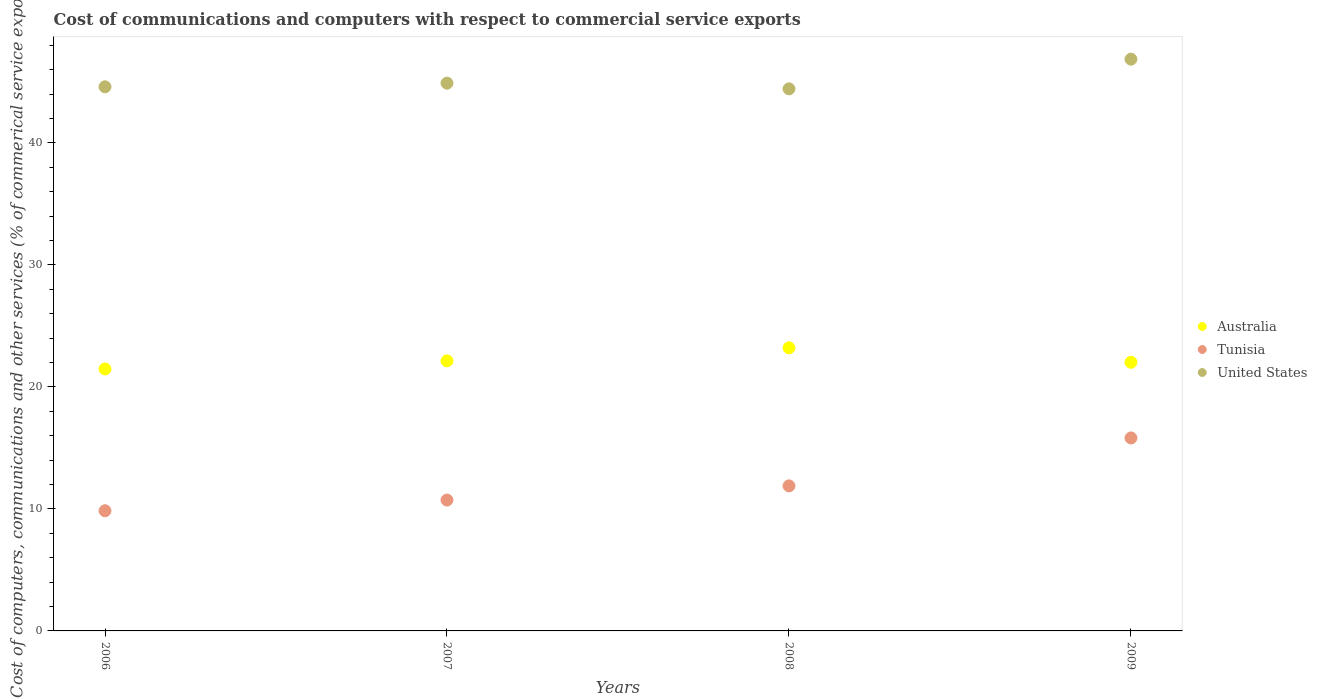How many different coloured dotlines are there?
Offer a terse response. 3. Is the number of dotlines equal to the number of legend labels?
Provide a succinct answer. Yes. What is the cost of communications and computers in United States in 2009?
Provide a short and direct response. 46.86. Across all years, what is the maximum cost of communications and computers in Australia?
Offer a terse response. 23.2. Across all years, what is the minimum cost of communications and computers in United States?
Provide a short and direct response. 44.43. In which year was the cost of communications and computers in Tunisia minimum?
Offer a very short reply. 2006. What is the total cost of communications and computers in Australia in the graph?
Offer a very short reply. 88.83. What is the difference between the cost of communications and computers in Tunisia in 2007 and that in 2009?
Provide a short and direct response. -5.09. What is the difference between the cost of communications and computers in United States in 2006 and the cost of communications and computers in Australia in 2007?
Provide a short and direct response. 22.46. What is the average cost of communications and computers in United States per year?
Provide a short and direct response. 45.2. In the year 2009, what is the difference between the cost of communications and computers in Tunisia and cost of communications and computers in Australia?
Provide a succinct answer. -6.2. In how many years, is the cost of communications and computers in Australia greater than 6 %?
Ensure brevity in your answer.  4. What is the ratio of the cost of communications and computers in Tunisia in 2008 to that in 2009?
Offer a very short reply. 0.75. Is the cost of communications and computers in United States in 2007 less than that in 2008?
Your answer should be compact. No. What is the difference between the highest and the second highest cost of communications and computers in Australia?
Offer a very short reply. 1.07. What is the difference between the highest and the lowest cost of communications and computers in Australia?
Your answer should be very brief. 1.73. In how many years, is the cost of communications and computers in Australia greater than the average cost of communications and computers in Australia taken over all years?
Offer a terse response. 1. Is the sum of the cost of communications and computers in Tunisia in 2006 and 2008 greater than the maximum cost of communications and computers in Australia across all years?
Your answer should be very brief. No. Is the cost of communications and computers in Australia strictly greater than the cost of communications and computers in United States over the years?
Ensure brevity in your answer.  No. How many dotlines are there?
Offer a terse response. 3. How many years are there in the graph?
Keep it short and to the point. 4. What is the difference between two consecutive major ticks on the Y-axis?
Your answer should be very brief. 10. Does the graph contain any zero values?
Your answer should be very brief. No. Where does the legend appear in the graph?
Offer a very short reply. Center right. How many legend labels are there?
Provide a short and direct response. 3. What is the title of the graph?
Your answer should be compact. Cost of communications and computers with respect to commercial service exports. Does "Uganda" appear as one of the legend labels in the graph?
Ensure brevity in your answer.  No. What is the label or title of the Y-axis?
Give a very brief answer. Cost of computers, communications and other services (% of commerical service exports). What is the Cost of computers, communications and other services (% of commerical service exports) of Australia in 2006?
Offer a terse response. 21.47. What is the Cost of computers, communications and other services (% of commerical service exports) of Tunisia in 2006?
Your answer should be compact. 9.85. What is the Cost of computers, communications and other services (% of commerical service exports) of United States in 2006?
Give a very brief answer. 44.6. What is the Cost of computers, communications and other services (% of commerical service exports) of Australia in 2007?
Keep it short and to the point. 22.14. What is the Cost of computers, communications and other services (% of commerical service exports) in Tunisia in 2007?
Offer a terse response. 10.73. What is the Cost of computers, communications and other services (% of commerical service exports) in United States in 2007?
Keep it short and to the point. 44.89. What is the Cost of computers, communications and other services (% of commerical service exports) in Australia in 2008?
Your response must be concise. 23.2. What is the Cost of computers, communications and other services (% of commerical service exports) of Tunisia in 2008?
Your answer should be compact. 11.89. What is the Cost of computers, communications and other services (% of commerical service exports) in United States in 2008?
Your answer should be very brief. 44.43. What is the Cost of computers, communications and other services (% of commerical service exports) in Australia in 2009?
Offer a very short reply. 22.02. What is the Cost of computers, communications and other services (% of commerical service exports) of Tunisia in 2009?
Ensure brevity in your answer.  15.82. What is the Cost of computers, communications and other services (% of commerical service exports) of United States in 2009?
Give a very brief answer. 46.86. Across all years, what is the maximum Cost of computers, communications and other services (% of commerical service exports) in Australia?
Offer a very short reply. 23.2. Across all years, what is the maximum Cost of computers, communications and other services (% of commerical service exports) in Tunisia?
Make the answer very short. 15.82. Across all years, what is the maximum Cost of computers, communications and other services (% of commerical service exports) of United States?
Provide a succinct answer. 46.86. Across all years, what is the minimum Cost of computers, communications and other services (% of commerical service exports) in Australia?
Your answer should be very brief. 21.47. Across all years, what is the minimum Cost of computers, communications and other services (% of commerical service exports) of Tunisia?
Provide a short and direct response. 9.85. Across all years, what is the minimum Cost of computers, communications and other services (% of commerical service exports) of United States?
Ensure brevity in your answer.  44.43. What is the total Cost of computers, communications and other services (% of commerical service exports) in Australia in the graph?
Offer a terse response. 88.83. What is the total Cost of computers, communications and other services (% of commerical service exports) of Tunisia in the graph?
Give a very brief answer. 48.28. What is the total Cost of computers, communications and other services (% of commerical service exports) of United States in the graph?
Keep it short and to the point. 180.78. What is the difference between the Cost of computers, communications and other services (% of commerical service exports) of Australia in 2006 and that in 2007?
Your answer should be very brief. -0.66. What is the difference between the Cost of computers, communications and other services (% of commerical service exports) of Tunisia in 2006 and that in 2007?
Give a very brief answer. -0.88. What is the difference between the Cost of computers, communications and other services (% of commerical service exports) in United States in 2006 and that in 2007?
Your response must be concise. -0.3. What is the difference between the Cost of computers, communications and other services (% of commerical service exports) in Australia in 2006 and that in 2008?
Ensure brevity in your answer.  -1.73. What is the difference between the Cost of computers, communications and other services (% of commerical service exports) of Tunisia in 2006 and that in 2008?
Provide a succinct answer. -2.04. What is the difference between the Cost of computers, communications and other services (% of commerical service exports) of United States in 2006 and that in 2008?
Offer a terse response. 0.17. What is the difference between the Cost of computers, communications and other services (% of commerical service exports) of Australia in 2006 and that in 2009?
Your answer should be very brief. -0.55. What is the difference between the Cost of computers, communications and other services (% of commerical service exports) of Tunisia in 2006 and that in 2009?
Your response must be concise. -5.97. What is the difference between the Cost of computers, communications and other services (% of commerical service exports) in United States in 2006 and that in 2009?
Ensure brevity in your answer.  -2.27. What is the difference between the Cost of computers, communications and other services (% of commerical service exports) in Australia in 2007 and that in 2008?
Offer a very short reply. -1.07. What is the difference between the Cost of computers, communications and other services (% of commerical service exports) of Tunisia in 2007 and that in 2008?
Make the answer very short. -1.16. What is the difference between the Cost of computers, communications and other services (% of commerical service exports) in United States in 2007 and that in 2008?
Provide a short and direct response. 0.46. What is the difference between the Cost of computers, communications and other services (% of commerical service exports) in Australia in 2007 and that in 2009?
Your answer should be compact. 0.12. What is the difference between the Cost of computers, communications and other services (% of commerical service exports) of Tunisia in 2007 and that in 2009?
Make the answer very short. -5.09. What is the difference between the Cost of computers, communications and other services (% of commerical service exports) in United States in 2007 and that in 2009?
Make the answer very short. -1.97. What is the difference between the Cost of computers, communications and other services (% of commerical service exports) of Australia in 2008 and that in 2009?
Offer a very short reply. 1.18. What is the difference between the Cost of computers, communications and other services (% of commerical service exports) in Tunisia in 2008 and that in 2009?
Ensure brevity in your answer.  -3.93. What is the difference between the Cost of computers, communications and other services (% of commerical service exports) in United States in 2008 and that in 2009?
Ensure brevity in your answer.  -2.43. What is the difference between the Cost of computers, communications and other services (% of commerical service exports) in Australia in 2006 and the Cost of computers, communications and other services (% of commerical service exports) in Tunisia in 2007?
Give a very brief answer. 10.75. What is the difference between the Cost of computers, communications and other services (% of commerical service exports) of Australia in 2006 and the Cost of computers, communications and other services (% of commerical service exports) of United States in 2007?
Your answer should be compact. -23.42. What is the difference between the Cost of computers, communications and other services (% of commerical service exports) of Tunisia in 2006 and the Cost of computers, communications and other services (% of commerical service exports) of United States in 2007?
Keep it short and to the point. -35.04. What is the difference between the Cost of computers, communications and other services (% of commerical service exports) of Australia in 2006 and the Cost of computers, communications and other services (% of commerical service exports) of Tunisia in 2008?
Offer a terse response. 9.58. What is the difference between the Cost of computers, communications and other services (% of commerical service exports) in Australia in 2006 and the Cost of computers, communications and other services (% of commerical service exports) in United States in 2008?
Offer a terse response. -22.96. What is the difference between the Cost of computers, communications and other services (% of commerical service exports) of Tunisia in 2006 and the Cost of computers, communications and other services (% of commerical service exports) of United States in 2008?
Your answer should be very brief. -34.58. What is the difference between the Cost of computers, communications and other services (% of commerical service exports) in Australia in 2006 and the Cost of computers, communications and other services (% of commerical service exports) in Tunisia in 2009?
Provide a succinct answer. 5.66. What is the difference between the Cost of computers, communications and other services (% of commerical service exports) of Australia in 2006 and the Cost of computers, communications and other services (% of commerical service exports) of United States in 2009?
Provide a short and direct response. -25.39. What is the difference between the Cost of computers, communications and other services (% of commerical service exports) in Tunisia in 2006 and the Cost of computers, communications and other services (% of commerical service exports) in United States in 2009?
Your response must be concise. -37.01. What is the difference between the Cost of computers, communications and other services (% of commerical service exports) in Australia in 2007 and the Cost of computers, communications and other services (% of commerical service exports) in Tunisia in 2008?
Give a very brief answer. 10.25. What is the difference between the Cost of computers, communications and other services (% of commerical service exports) in Australia in 2007 and the Cost of computers, communications and other services (% of commerical service exports) in United States in 2008?
Keep it short and to the point. -22.29. What is the difference between the Cost of computers, communications and other services (% of commerical service exports) in Tunisia in 2007 and the Cost of computers, communications and other services (% of commerical service exports) in United States in 2008?
Offer a very short reply. -33.7. What is the difference between the Cost of computers, communications and other services (% of commerical service exports) of Australia in 2007 and the Cost of computers, communications and other services (% of commerical service exports) of Tunisia in 2009?
Your answer should be very brief. 6.32. What is the difference between the Cost of computers, communications and other services (% of commerical service exports) in Australia in 2007 and the Cost of computers, communications and other services (% of commerical service exports) in United States in 2009?
Your answer should be very brief. -24.73. What is the difference between the Cost of computers, communications and other services (% of commerical service exports) of Tunisia in 2007 and the Cost of computers, communications and other services (% of commerical service exports) of United States in 2009?
Your answer should be very brief. -36.14. What is the difference between the Cost of computers, communications and other services (% of commerical service exports) in Australia in 2008 and the Cost of computers, communications and other services (% of commerical service exports) in Tunisia in 2009?
Offer a terse response. 7.39. What is the difference between the Cost of computers, communications and other services (% of commerical service exports) in Australia in 2008 and the Cost of computers, communications and other services (% of commerical service exports) in United States in 2009?
Give a very brief answer. -23.66. What is the difference between the Cost of computers, communications and other services (% of commerical service exports) in Tunisia in 2008 and the Cost of computers, communications and other services (% of commerical service exports) in United States in 2009?
Provide a succinct answer. -34.98. What is the average Cost of computers, communications and other services (% of commerical service exports) in Australia per year?
Make the answer very short. 22.21. What is the average Cost of computers, communications and other services (% of commerical service exports) of Tunisia per year?
Provide a succinct answer. 12.07. What is the average Cost of computers, communications and other services (% of commerical service exports) of United States per year?
Your answer should be very brief. 45.2. In the year 2006, what is the difference between the Cost of computers, communications and other services (% of commerical service exports) of Australia and Cost of computers, communications and other services (% of commerical service exports) of Tunisia?
Keep it short and to the point. 11.62. In the year 2006, what is the difference between the Cost of computers, communications and other services (% of commerical service exports) in Australia and Cost of computers, communications and other services (% of commerical service exports) in United States?
Provide a short and direct response. -23.12. In the year 2006, what is the difference between the Cost of computers, communications and other services (% of commerical service exports) in Tunisia and Cost of computers, communications and other services (% of commerical service exports) in United States?
Your response must be concise. -34.75. In the year 2007, what is the difference between the Cost of computers, communications and other services (% of commerical service exports) in Australia and Cost of computers, communications and other services (% of commerical service exports) in Tunisia?
Your response must be concise. 11.41. In the year 2007, what is the difference between the Cost of computers, communications and other services (% of commerical service exports) in Australia and Cost of computers, communications and other services (% of commerical service exports) in United States?
Your response must be concise. -22.76. In the year 2007, what is the difference between the Cost of computers, communications and other services (% of commerical service exports) of Tunisia and Cost of computers, communications and other services (% of commerical service exports) of United States?
Keep it short and to the point. -34.17. In the year 2008, what is the difference between the Cost of computers, communications and other services (% of commerical service exports) in Australia and Cost of computers, communications and other services (% of commerical service exports) in Tunisia?
Provide a short and direct response. 11.32. In the year 2008, what is the difference between the Cost of computers, communications and other services (% of commerical service exports) in Australia and Cost of computers, communications and other services (% of commerical service exports) in United States?
Ensure brevity in your answer.  -21.23. In the year 2008, what is the difference between the Cost of computers, communications and other services (% of commerical service exports) in Tunisia and Cost of computers, communications and other services (% of commerical service exports) in United States?
Keep it short and to the point. -32.54. In the year 2009, what is the difference between the Cost of computers, communications and other services (% of commerical service exports) of Australia and Cost of computers, communications and other services (% of commerical service exports) of Tunisia?
Your answer should be compact. 6.2. In the year 2009, what is the difference between the Cost of computers, communications and other services (% of commerical service exports) in Australia and Cost of computers, communications and other services (% of commerical service exports) in United States?
Make the answer very short. -24.84. In the year 2009, what is the difference between the Cost of computers, communications and other services (% of commerical service exports) of Tunisia and Cost of computers, communications and other services (% of commerical service exports) of United States?
Provide a short and direct response. -31.05. What is the ratio of the Cost of computers, communications and other services (% of commerical service exports) in Australia in 2006 to that in 2007?
Ensure brevity in your answer.  0.97. What is the ratio of the Cost of computers, communications and other services (% of commerical service exports) in Tunisia in 2006 to that in 2007?
Provide a short and direct response. 0.92. What is the ratio of the Cost of computers, communications and other services (% of commerical service exports) in United States in 2006 to that in 2007?
Offer a terse response. 0.99. What is the ratio of the Cost of computers, communications and other services (% of commerical service exports) of Australia in 2006 to that in 2008?
Offer a terse response. 0.93. What is the ratio of the Cost of computers, communications and other services (% of commerical service exports) in Tunisia in 2006 to that in 2008?
Offer a terse response. 0.83. What is the ratio of the Cost of computers, communications and other services (% of commerical service exports) in Australia in 2006 to that in 2009?
Give a very brief answer. 0.98. What is the ratio of the Cost of computers, communications and other services (% of commerical service exports) in Tunisia in 2006 to that in 2009?
Keep it short and to the point. 0.62. What is the ratio of the Cost of computers, communications and other services (% of commerical service exports) of United States in 2006 to that in 2009?
Your answer should be compact. 0.95. What is the ratio of the Cost of computers, communications and other services (% of commerical service exports) in Australia in 2007 to that in 2008?
Your response must be concise. 0.95. What is the ratio of the Cost of computers, communications and other services (% of commerical service exports) in Tunisia in 2007 to that in 2008?
Give a very brief answer. 0.9. What is the ratio of the Cost of computers, communications and other services (% of commerical service exports) of United States in 2007 to that in 2008?
Your response must be concise. 1.01. What is the ratio of the Cost of computers, communications and other services (% of commerical service exports) in Tunisia in 2007 to that in 2009?
Your response must be concise. 0.68. What is the ratio of the Cost of computers, communications and other services (% of commerical service exports) of United States in 2007 to that in 2009?
Provide a succinct answer. 0.96. What is the ratio of the Cost of computers, communications and other services (% of commerical service exports) of Australia in 2008 to that in 2009?
Offer a terse response. 1.05. What is the ratio of the Cost of computers, communications and other services (% of commerical service exports) in Tunisia in 2008 to that in 2009?
Provide a short and direct response. 0.75. What is the ratio of the Cost of computers, communications and other services (% of commerical service exports) of United States in 2008 to that in 2009?
Make the answer very short. 0.95. What is the difference between the highest and the second highest Cost of computers, communications and other services (% of commerical service exports) of Australia?
Make the answer very short. 1.07. What is the difference between the highest and the second highest Cost of computers, communications and other services (% of commerical service exports) in Tunisia?
Your answer should be very brief. 3.93. What is the difference between the highest and the second highest Cost of computers, communications and other services (% of commerical service exports) in United States?
Offer a very short reply. 1.97. What is the difference between the highest and the lowest Cost of computers, communications and other services (% of commerical service exports) of Australia?
Give a very brief answer. 1.73. What is the difference between the highest and the lowest Cost of computers, communications and other services (% of commerical service exports) in Tunisia?
Provide a short and direct response. 5.97. What is the difference between the highest and the lowest Cost of computers, communications and other services (% of commerical service exports) of United States?
Make the answer very short. 2.43. 